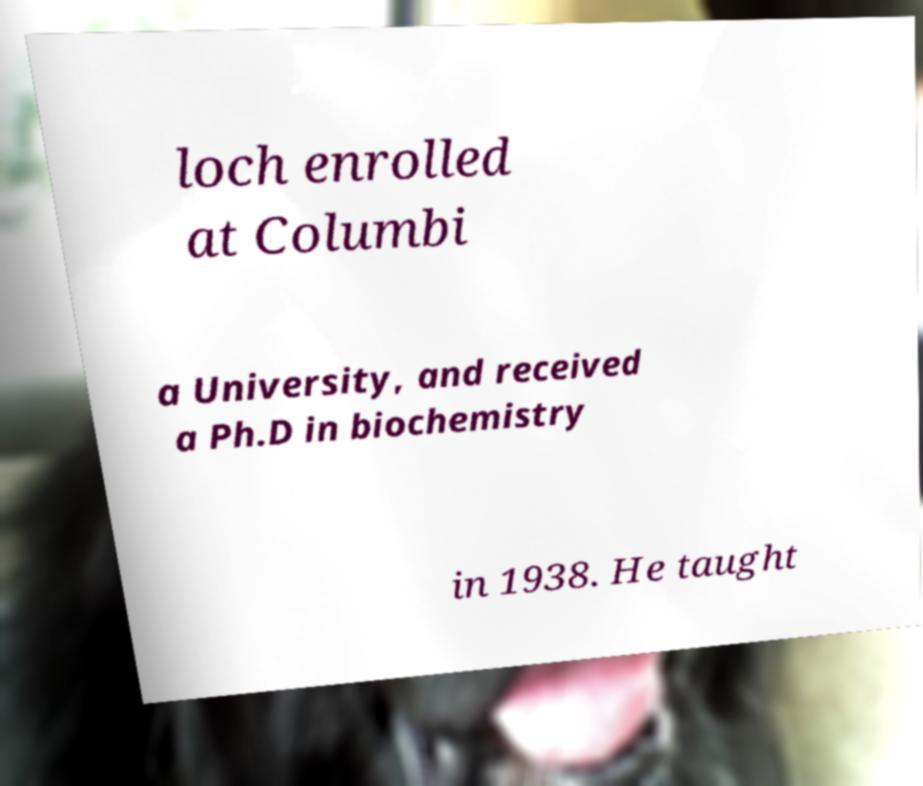Please read and relay the text visible in this image. What does it say? loch enrolled at Columbi a University, and received a Ph.D in biochemistry in 1938. He taught 